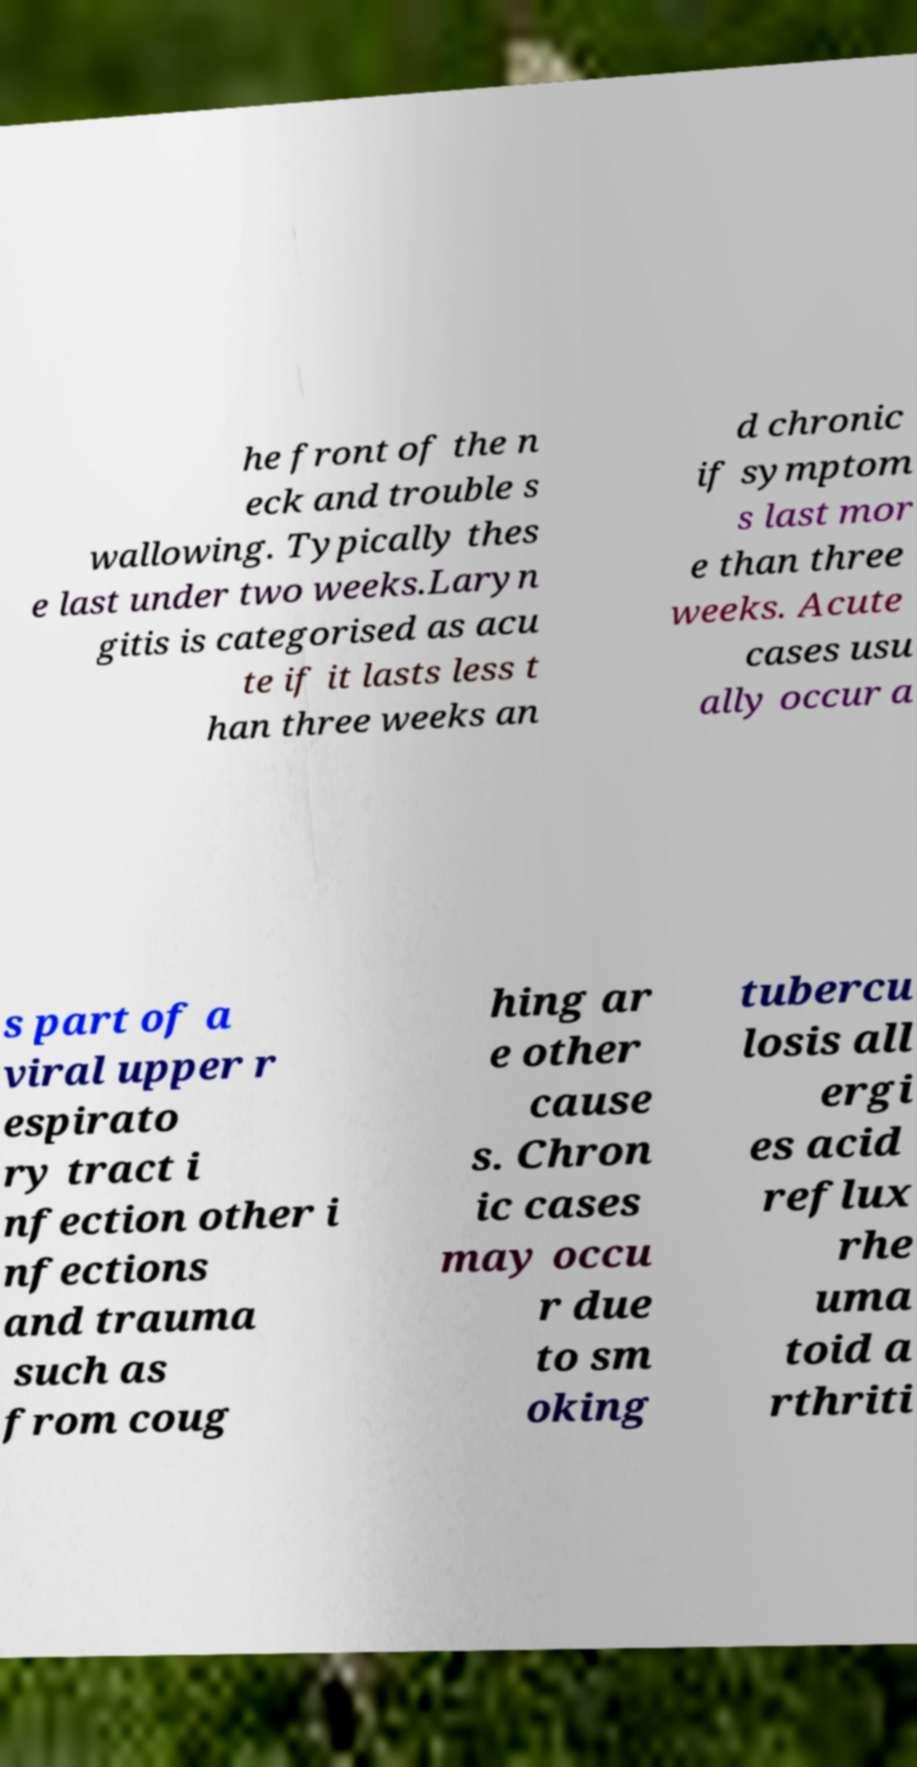I need the written content from this picture converted into text. Can you do that? he front of the n eck and trouble s wallowing. Typically thes e last under two weeks.Laryn gitis is categorised as acu te if it lasts less t han three weeks an d chronic if symptom s last mor e than three weeks. Acute cases usu ally occur a s part of a viral upper r espirato ry tract i nfection other i nfections and trauma such as from coug hing ar e other cause s. Chron ic cases may occu r due to sm oking tubercu losis all ergi es acid reflux rhe uma toid a rthriti 